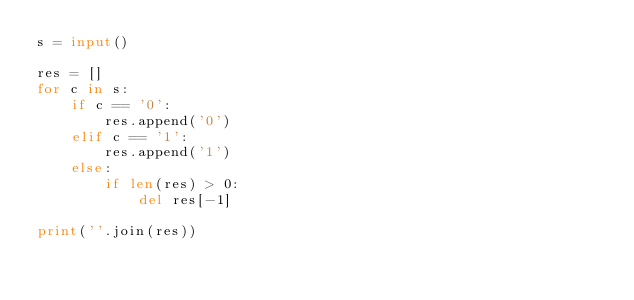<code> <loc_0><loc_0><loc_500><loc_500><_Python_>s = input()

res = []
for c in s:
    if c == '0':
        res.append('0')
    elif c == '1':
        res.append('1')
    else:
        if len(res) > 0:
            del res[-1]

print(''.join(res))</code> 